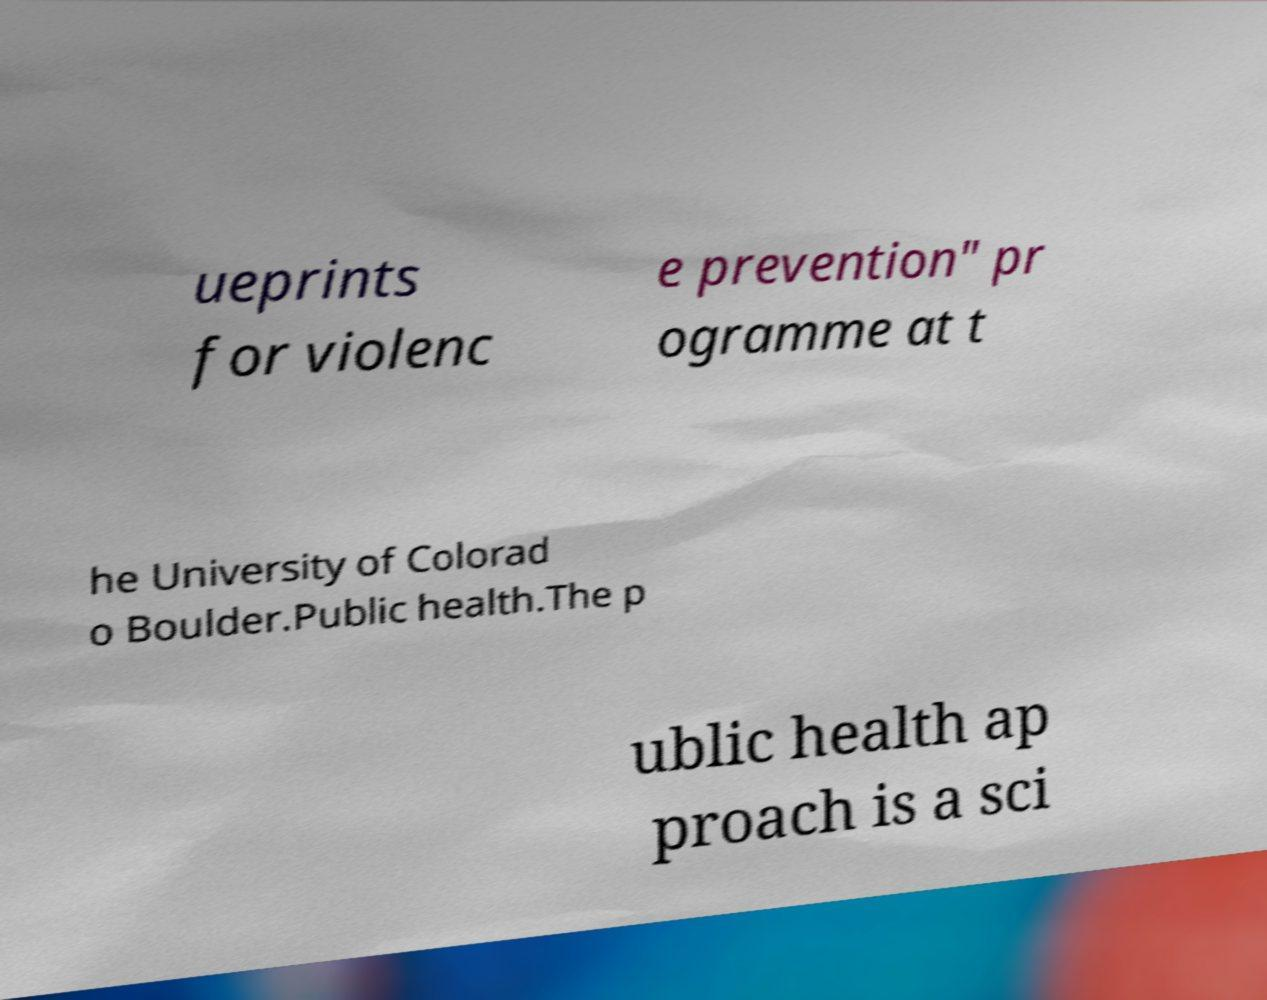Could you extract and type out the text from this image? ueprints for violenc e prevention" pr ogramme at t he University of Colorad o Boulder.Public health.The p ublic health ap proach is a sci 